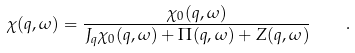<formula> <loc_0><loc_0><loc_500><loc_500>\chi ( { q } , \omega ) = \frac { \chi _ { 0 } ( { q } , \omega ) } { J _ { q } \chi _ { 0 } ( { q } , \omega ) + \Pi ( { q } , \omega ) + Z ( { q } , \omega ) } \quad .</formula> 